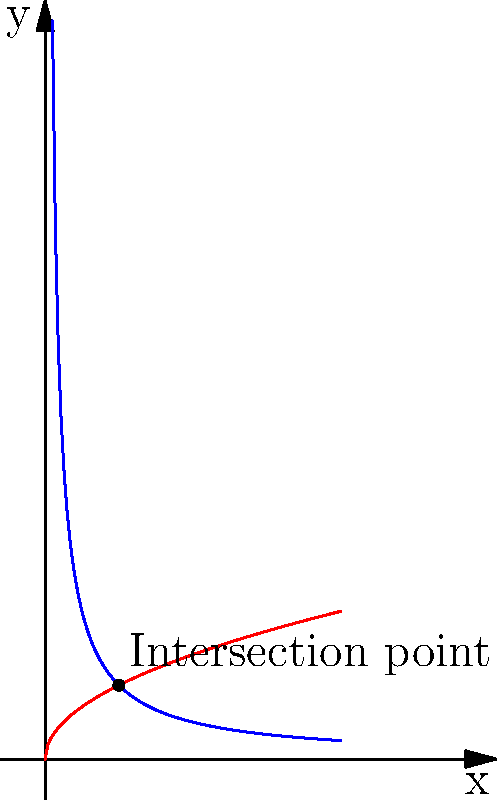Consider two spacecraft in different orbital paths around a celestial body. One follows a hyperbolic orbit described by the function $y = \frac{1}{x}$, while the other follows an elliptical orbit described by $y = \sqrt{x}$. At what point do these orbits intersect, and what implications does this have for space traffic management? To find the intersection point of the two orbits, we need to solve the equation:

$$\frac{1}{x} = \sqrt{x}$$

Step 1: Square both sides to eliminate the square root:
$$(\frac{1}{x})^2 = (\sqrt{x})^2$$

Step 2: Simplify:
$$\frac{1}{x^2} = x$$

Step 3: Multiply both sides by $x^2$:
$$1 = x^3$$

Step 4: The solution to this equation is $x = 1$. To find the corresponding y-value, substitute $x = 1$ into either original equation:

$$y = \frac{1}{1} = 1$$ or $$y = \sqrt{1} = 1$$

Therefore, the intersection point is (1, 1).

Implications for space traffic management:
1. This intersection point represents a potential collision risk for the two spacecraft.
2. It highlights the need for precise orbital calculations and tracking.
3. It demonstrates the importance of coordination between different space missions.
4. It underscores the need for international cooperation in space traffic management to ensure the safety of all spacecraft and astronauts.
5. It shows that even drastically different orbit types can intersect, emphasizing the complexity of managing space traffic in three dimensions.
Answer: (1, 1); potential collision point requiring international space traffic management 